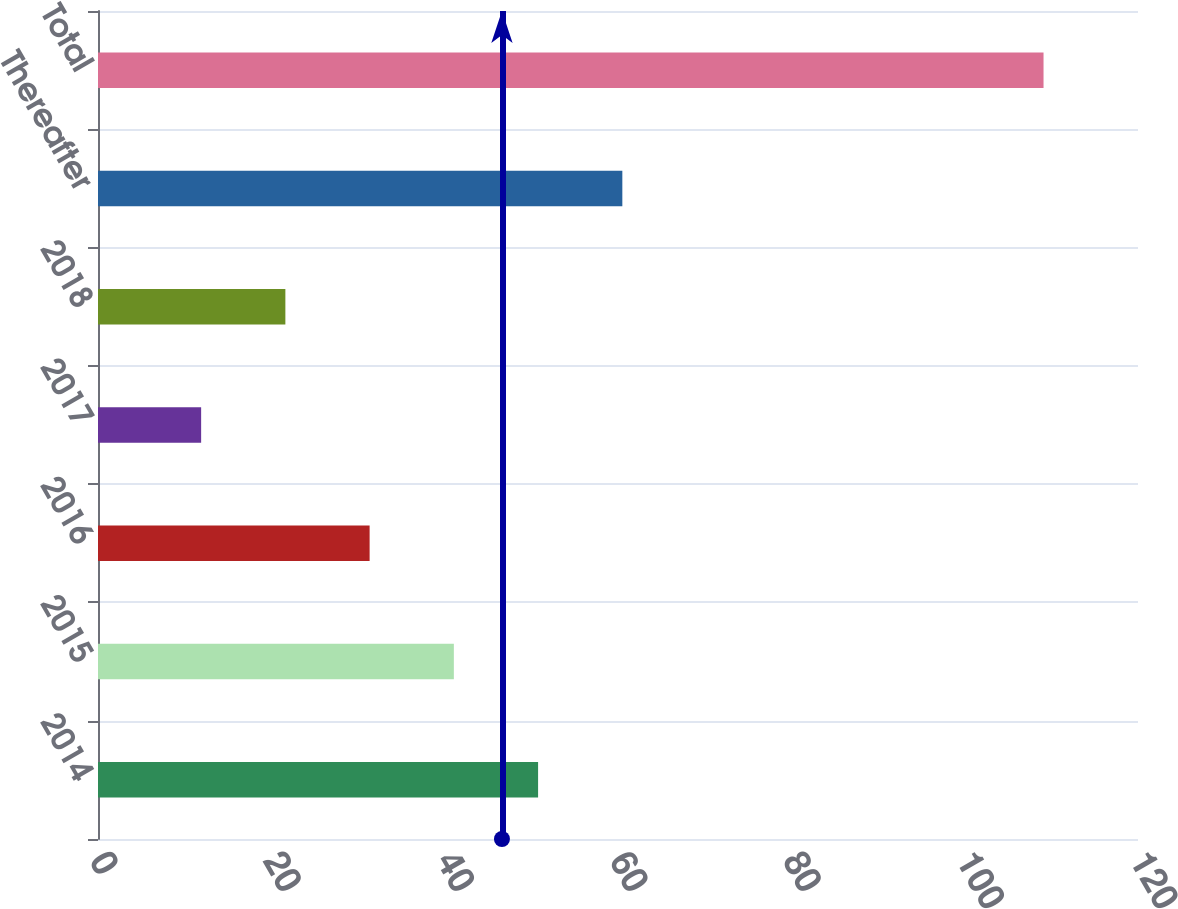Convert chart to OTSL. <chart><loc_0><loc_0><loc_500><loc_500><bar_chart><fcel>2014<fcel>2015<fcel>2016<fcel>2017<fcel>2018<fcel>Thereafter<fcel>Total<nl><fcel>50.78<fcel>41.06<fcel>31.34<fcel>11.9<fcel>21.62<fcel>60.5<fcel>109.1<nl></chart> 